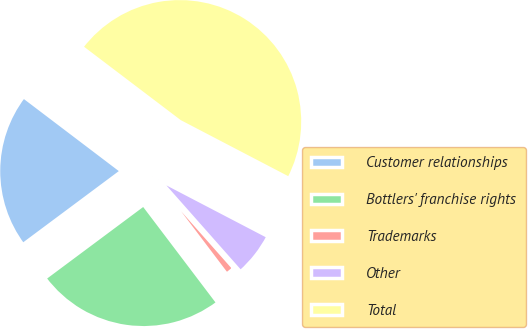Convert chart to OTSL. <chart><loc_0><loc_0><loc_500><loc_500><pie_chart><fcel>Customer relationships<fcel>Bottlers' franchise rights<fcel>Trademarks<fcel>Other<fcel>Total<nl><fcel>20.52%<fcel>25.13%<fcel>1.21%<fcel>5.82%<fcel>47.32%<nl></chart> 